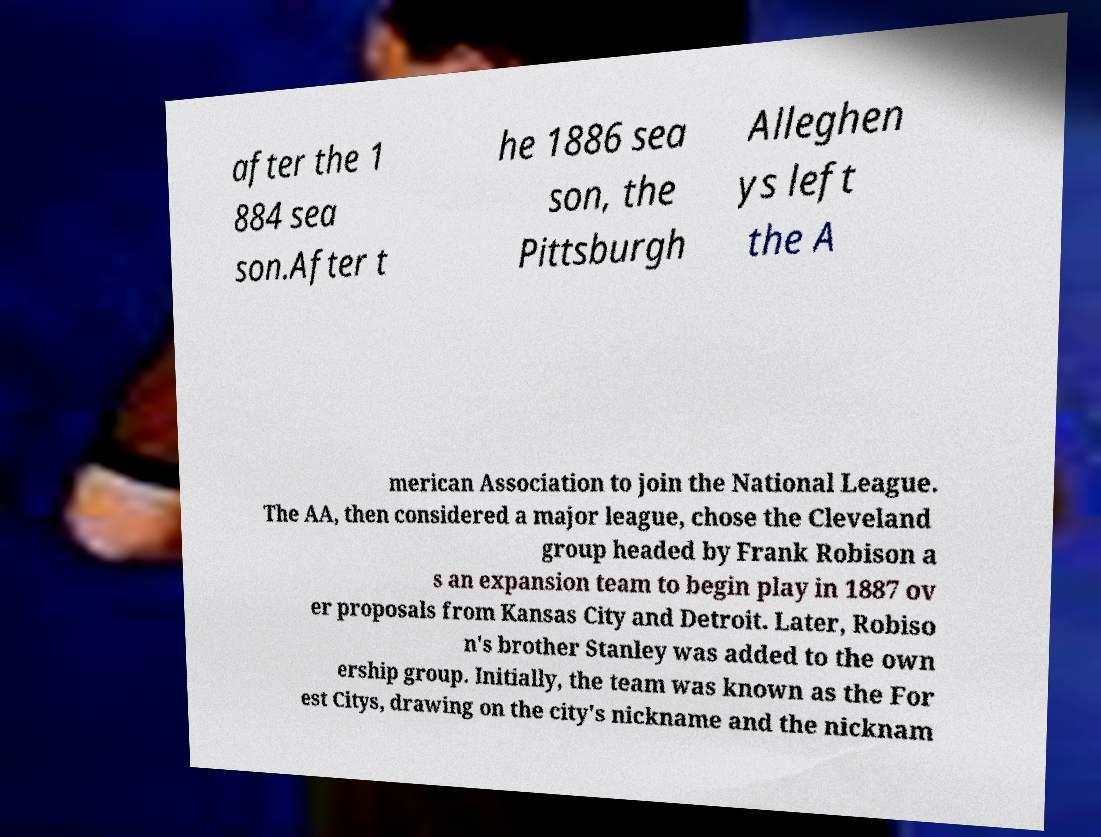Please identify and transcribe the text found in this image. after the 1 884 sea son.After t he 1886 sea son, the Pittsburgh Alleghen ys left the A merican Association to join the National League. The AA, then considered a major league, chose the Cleveland group headed by Frank Robison a s an expansion team to begin play in 1887 ov er proposals from Kansas City and Detroit. Later, Robiso n's brother Stanley was added to the own ership group. Initially, the team was known as the For est Citys, drawing on the city's nickname and the nicknam 